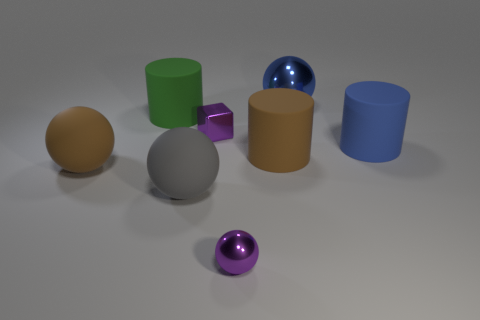Add 1 brown balls. How many objects exist? 9 Subtract all blocks. How many objects are left? 7 Add 7 blue matte cylinders. How many blue matte cylinders are left? 8 Add 5 tiny brown cylinders. How many tiny brown cylinders exist? 5 Subtract 0 cyan blocks. How many objects are left? 8 Subtract all brown metallic spheres. Subtract all purple metal balls. How many objects are left? 7 